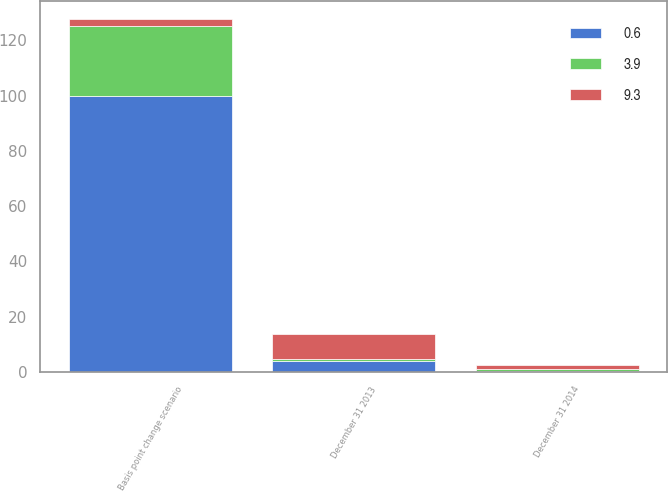<chart> <loc_0><loc_0><loc_500><loc_500><stacked_bar_chart><ecel><fcel>Basis point change scenario<fcel>December 31 2014<fcel>December 31 2013<nl><fcel>3.9<fcel>25<fcel>0.6<fcel>0.6<nl><fcel>0.6<fcel>100<fcel>0.4<fcel>3.9<nl><fcel>9.3<fcel>2.7<fcel>1.5<fcel>9.3<nl></chart> 